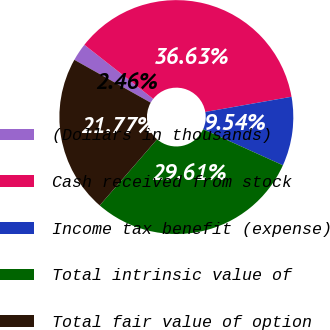Convert chart to OTSL. <chart><loc_0><loc_0><loc_500><loc_500><pie_chart><fcel>(Dollars in thousands)<fcel>Cash received from stock<fcel>Income tax benefit (expense)<fcel>Total intrinsic value of<fcel>Total fair value of option<nl><fcel>2.46%<fcel>36.63%<fcel>9.54%<fcel>29.61%<fcel>21.77%<nl></chart> 